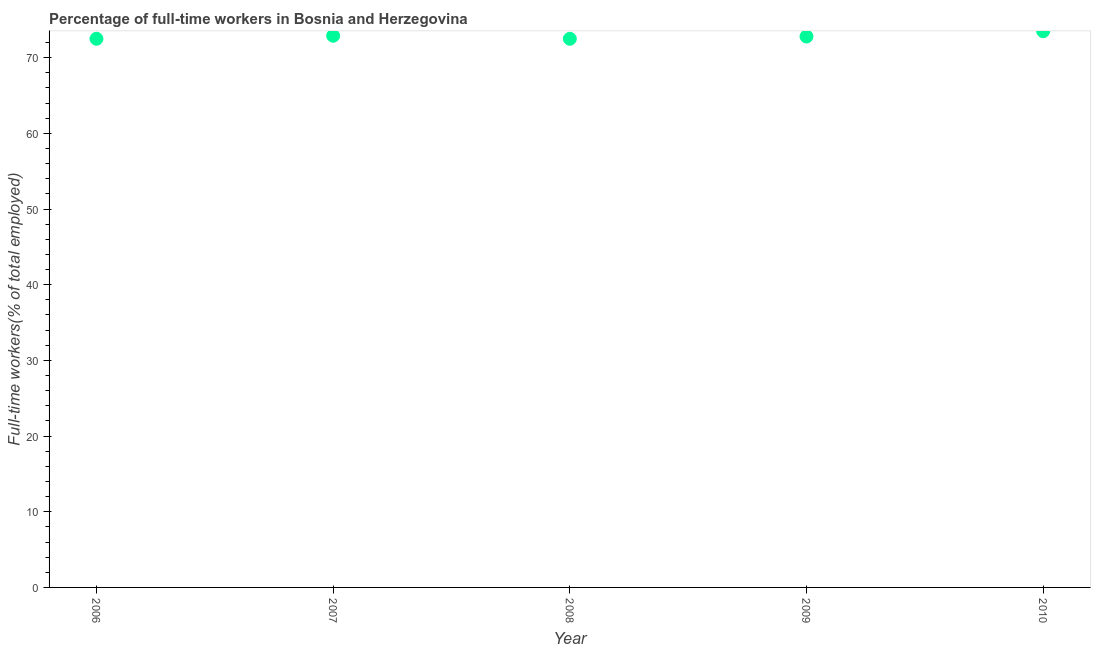What is the percentage of full-time workers in 2008?
Offer a terse response. 72.5. Across all years, what is the maximum percentage of full-time workers?
Make the answer very short. 73.5. Across all years, what is the minimum percentage of full-time workers?
Provide a succinct answer. 72.5. In which year was the percentage of full-time workers minimum?
Keep it short and to the point. 2006. What is the sum of the percentage of full-time workers?
Your answer should be very brief. 364.2. What is the average percentage of full-time workers per year?
Keep it short and to the point. 72.84. What is the median percentage of full-time workers?
Provide a succinct answer. 72.8. In how many years, is the percentage of full-time workers greater than 28 %?
Your response must be concise. 5. What is the ratio of the percentage of full-time workers in 2006 to that in 2010?
Give a very brief answer. 0.99. Is the percentage of full-time workers in 2006 less than that in 2007?
Your answer should be compact. Yes. Is the difference between the percentage of full-time workers in 2007 and 2009 greater than the difference between any two years?
Make the answer very short. No. What is the difference between the highest and the second highest percentage of full-time workers?
Your answer should be very brief. 0.6. Is the sum of the percentage of full-time workers in 2007 and 2009 greater than the maximum percentage of full-time workers across all years?
Offer a terse response. Yes. What is the difference between the highest and the lowest percentage of full-time workers?
Give a very brief answer. 1. In how many years, is the percentage of full-time workers greater than the average percentage of full-time workers taken over all years?
Give a very brief answer. 2. How many dotlines are there?
Ensure brevity in your answer.  1. How many years are there in the graph?
Provide a short and direct response. 5. Does the graph contain any zero values?
Your response must be concise. No. What is the title of the graph?
Make the answer very short. Percentage of full-time workers in Bosnia and Herzegovina. What is the label or title of the X-axis?
Provide a succinct answer. Year. What is the label or title of the Y-axis?
Keep it short and to the point. Full-time workers(% of total employed). What is the Full-time workers(% of total employed) in 2006?
Ensure brevity in your answer.  72.5. What is the Full-time workers(% of total employed) in 2007?
Give a very brief answer. 72.9. What is the Full-time workers(% of total employed) in 2008?
Your answer should be very brief. 72.5. What is the Full-time workers(% of total employed) in 2009?
Make the answer very short. 72.8. What is the Full-time workers(% of total employed) in 2010?
Make the answer very short. 73.5. What is the difference between the Full-time workers(% of total employed) in 2006 and 2007?
Offer a very short reply. -0.4. What is the difference between the Full-time workers(% of total employed) in 2007 and 2008?
Give a very brief answer. 0.4. What is the difference between the Full-time workers(% of total employed) in 2007 and 2009?
Your answer should be very brief. 0.1. What is the difference between the Full-time workers(% of total employed) in 2008 and 2010?
Give a very brief answer. -1. What is the ratio of the Full-time workers(% of total employed) in 2006 to that in 2009?
Provide a short and direct response. 1. What is the ratio of the Full-time workers(% of total employed) in 2006 to that in 2010?
Provide a succinct answer. 0.99. What is the ratio of the Full-time workers(% of total employed) in 2008 to that in 2009?
Your response must be concise. 1. 